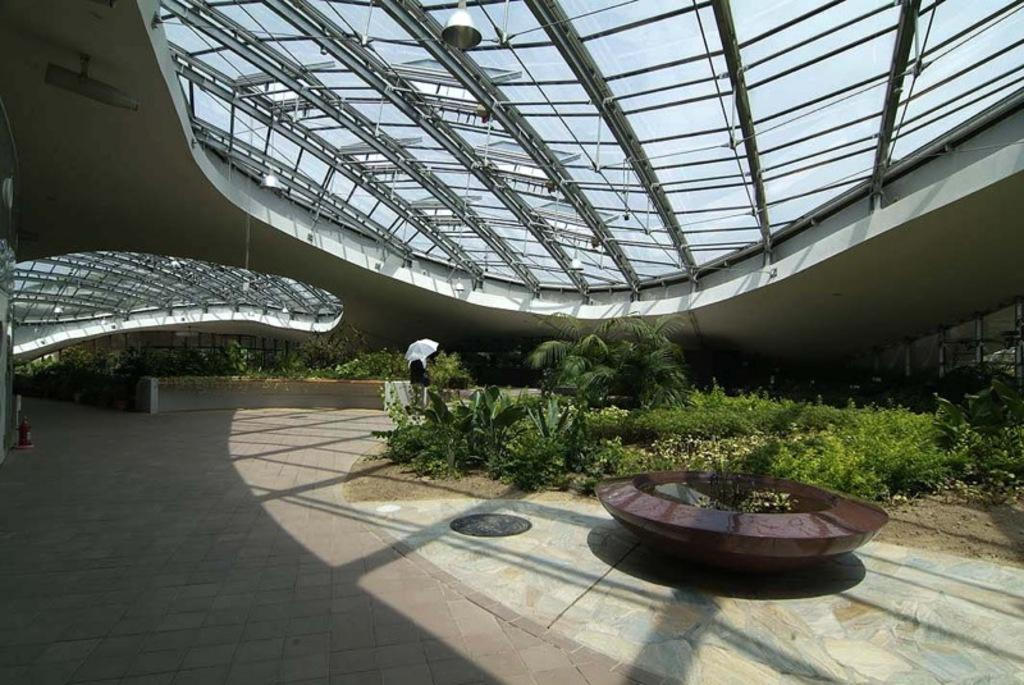What type of location is depicted in the image? The image is an inside view of a building. building. What can be seen on the ground in the image? There are many plants on the ground in the image. What part of the building can be seen at the bottom of the image? The floor is visible at the bottom of the image. What materials are present at the top of the image? There are metal rods and glass present at the top of the image. What type of pen can be seen writing in the image? There is no pen present in the image. 